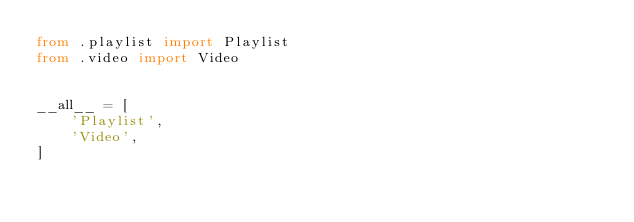<code> <loc_0><loc_0><loc_500><loc_500><_Python_>from .playlist import Playlist
from .video import Video


__all__ = [
    'Playlist',
    'Video',
]
</code> 